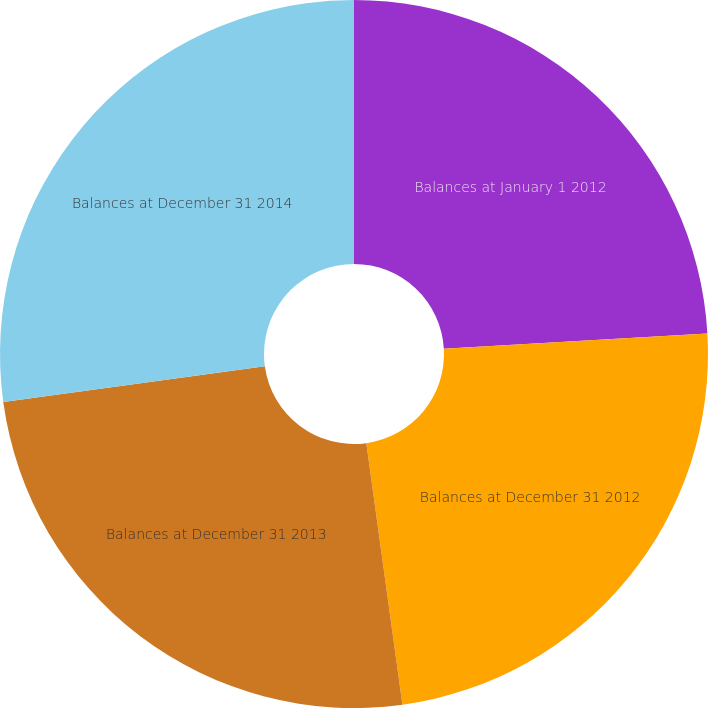Convert chart. <chart><loc_0><loc_0><loc_500><loc_500><pie_chart><fcel>Balances at January 1 2012<fcel>Balances at December 31 2012<fcel>Balances at December 31 2013<fcel>Balances at December 31 2014<nl><fcel>24.08%<fcel>23.74%<fcel>25.02%<fcel>27.17%<nl></chart> 